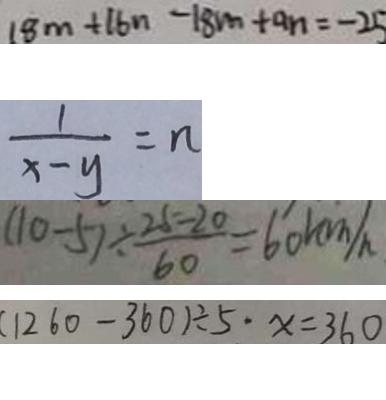Convert formula to latex. <formula><loc_0><loc_0><loc_500><loc_500>1 8 m + 1 6 n - 1 8 m + a n = - 2 5 
 \frac { 1 } { x - y } = n 
 ( 1 0 - 5 ) \div \frac { 2 5 - 2 0 } { 6 0 } = 6 0 k m / h 
 ( 1 2 6 0 - 3 6 0 ) \div 5 \cdot x = 3 6 0</formula> 